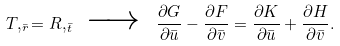<formula> <loc_0><loc_0><loc_500><loc_500>T , _ { \bar { r } } = R , _ { \bar { t } } \ \xrightarrow { \quad } \ \frac { \partial G } { \partial \bar { u } } - \frac { \partial F } { \partial \bar { v } } = \frac { \partial K } { \partial \bar { u } } + \frac { \partial H } { \partial \bar { v } } .</formula> 